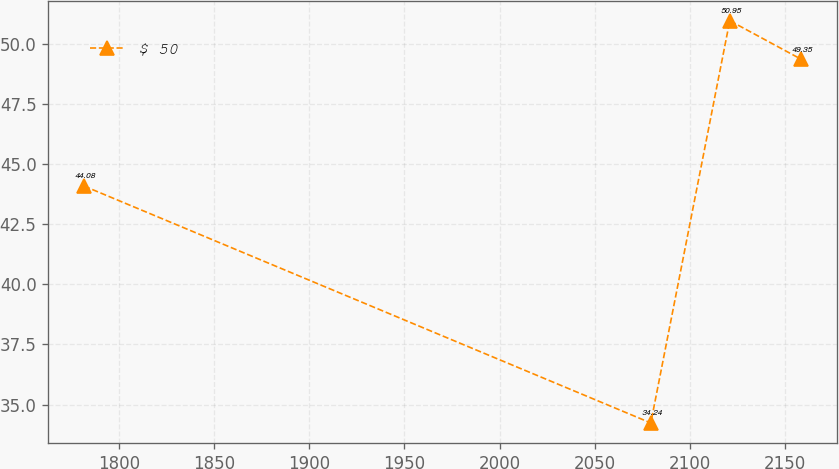<chart> <loc_0><loc_0><loc_500><loc_500><line_chart><ecel><fcel>$ 50<nl><fcel>1781.82<fcel>44.08<nl><fcel>2079.42<fcel>34.24<nl><fcel>2120.9<fcel>50.95<nl><fcel>2158.35<fcel>49.35<nl></chart> 